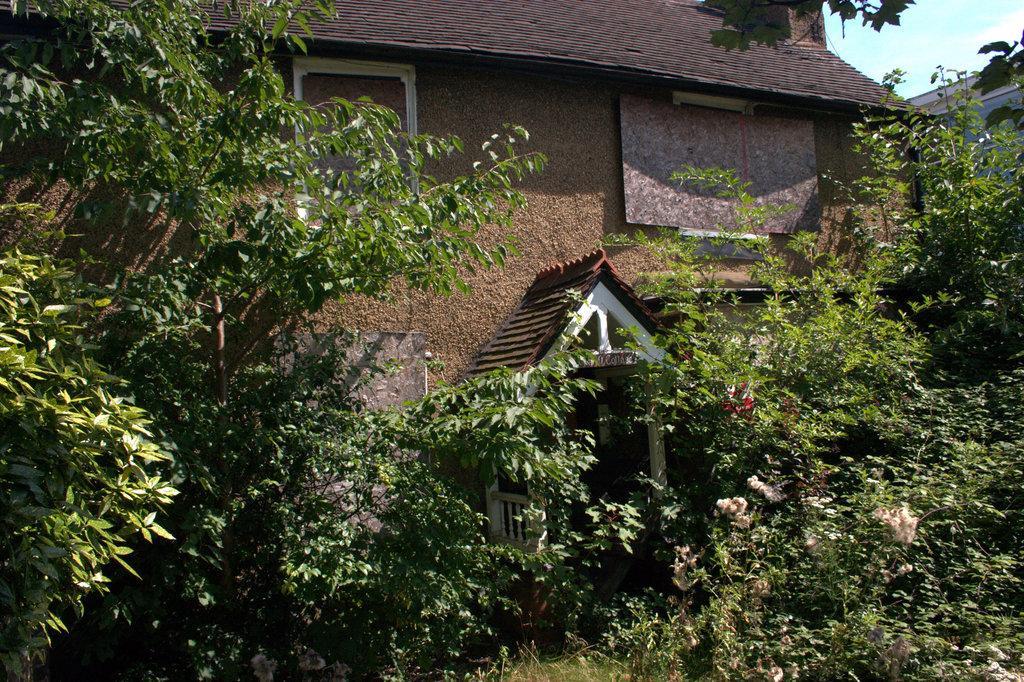In one or two sentences, can you explain what this image depicts? In this image we can see there is a house, in front of the house there are trees and plants. 